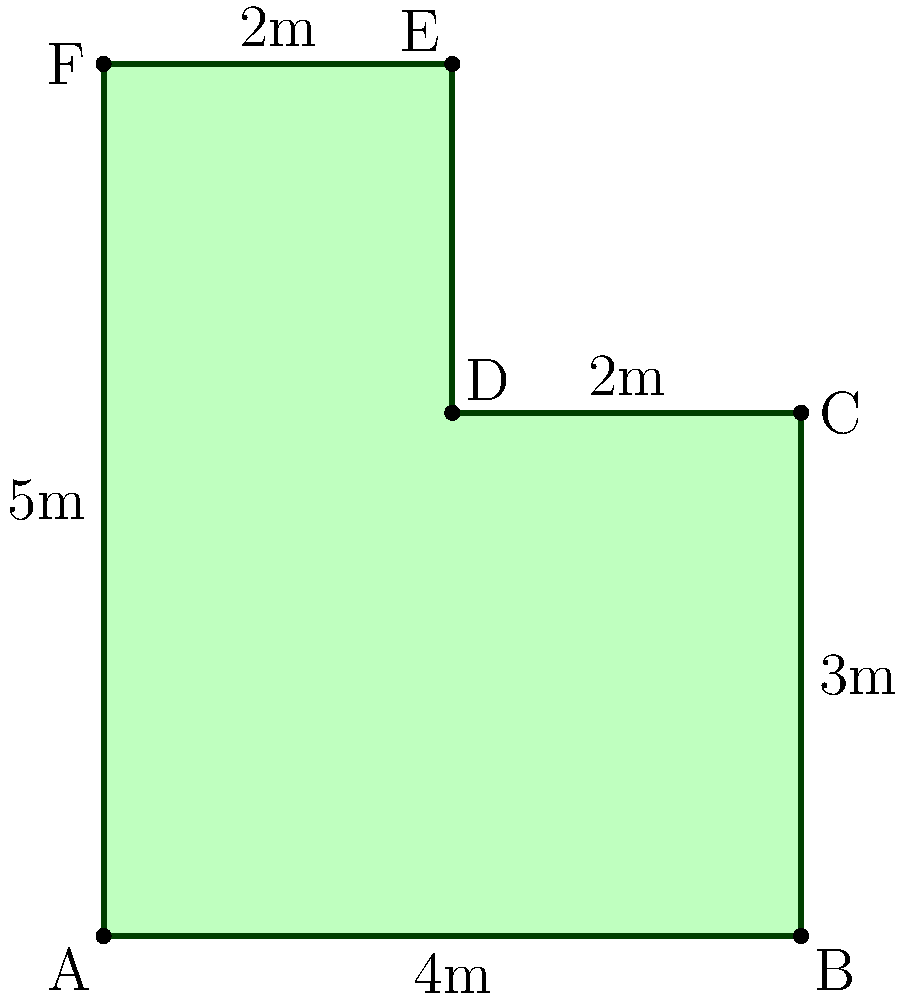As a customer support representative with a passion for gardening, you're designing an irregularly shaped garden plot. The plot is represented by the green shape in the diagram. Calculate the total area of this garden plot in square meters. To calculate the area of this irregularly shaped garden plot, we can divide it into two rectangles and add their areas together:

1. Lower rectangle (ABCD):
   Width = 4m
   Height = 3m
   Area of lower rectangle = $4m \times 3m = 12m^2$

2. Upper rectangle (ADEF):
   Width = 2m
   Height = 5m
   Area of upper rectangle = $2m \times 5m = 10m^2$

3. Total area:
   Total area = Area of lower rectangle + Area of upper rectangle
               = $12m^2 + 10m^2 = 22m^2$

Therefore, the total area of the irregularly shaped garden plot is $22m^2$.
Answer: $22m^2$ 